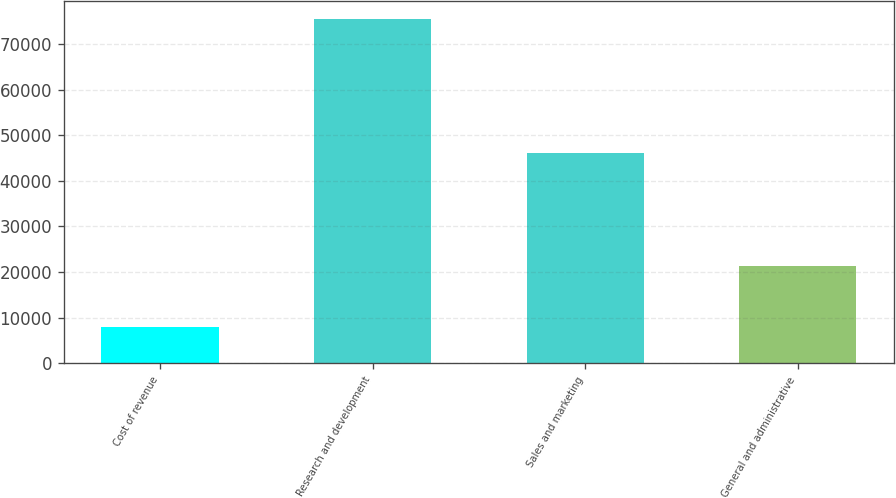<chart> <loc_0><loc_0><loc_500><loc_500><bar_chart><fcel>Cost of revenue<fcel>Research and development<fcel>Sales and marketing<fcel>General and administrative<nl><fcel>7968<fcel>75579<fcel>46101<fcel>21268<nl></chart> 